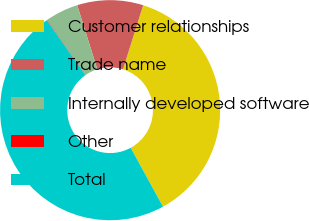<chart> <loc_0><loc_0><loc_500><loc_500><pie_chart><fcel>Customer relationships<fcel>Trade name<fcel>Internally developed software<fcel>Other<fcel>Total<nl><fcel>37.17%<fcel>9.69%<fcel>4.88%<fcel>0.06%<fcel>48.2%<nl></chart> 